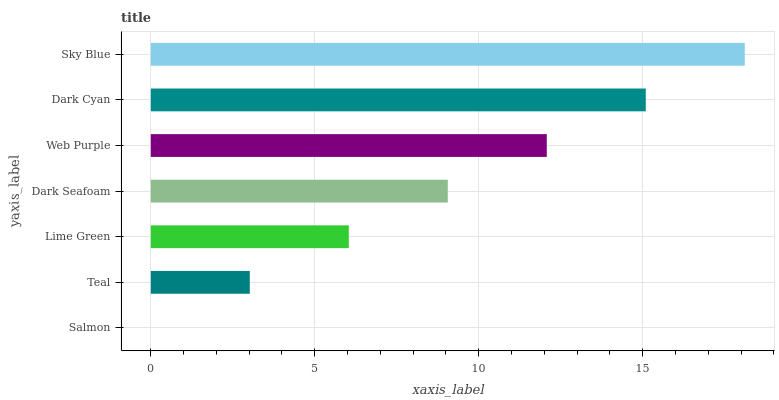Is Salmon the minimum?
Answer yes or no. Yes. Is Sky Blue the maximum?
Answer yes or no. Yes. Is Teal the minimum?
Answer yes or no. No. Is Teal the maximum?
Answer yes or no. No. Is Teal greater than Salmon?
Answer yes or no. Yes. Is Salmon less than Teal?
Answer yes or no. Yes. Is Salmon greater than Teal?
Answer yes or no. No. Is Teal less than Salmon?
Answer yes or no. No. Is Dark Seafoam the high median?
Answer yes or no. Yes. Is Dark Seafoam the low median?
Answer yes or no. Yes. Is Lime Green the high median?
Answer yes or no. No. Is Dark Cyan the low median?
Answer yes or no. No. 